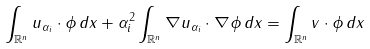Convert formula to latex. <formula><loc_0><loc_0><loc_500><loc_500>\int _ { \mathbb { R } ^ { n } } u _ { \alpha _ { i } } \cdot \phi \, d x + \alpha _ { i } ^ { 2 } \int _ { \mathbb { R } ^ { n } } \nabla u _ { \alpha _ { i } } \cdot \nabla \phi \, d x = \int _ { \mathbb { R } ^ { n } } v \cdot \phi \, d x</formula> 